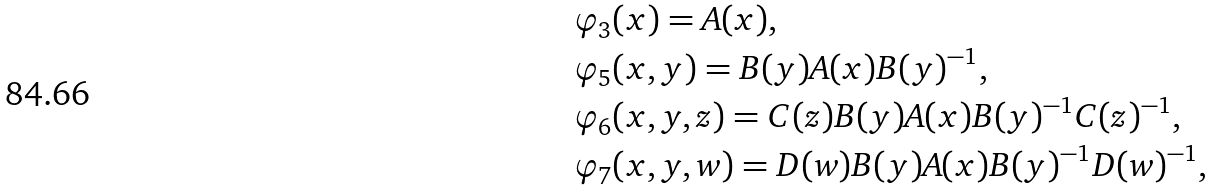<formula> <loc_0><loc_0><loc_500><loc_500>& \varphi _ { 3 } ( { x } ) = A ( { x } ) , \\ & \varphi _ { 5 } ( { x } , { y } ) = B ( { y } ) A ( { x } ) B ( { y } ) ^ { - 1 } , \\ & \varphi _ { 6 } ( { x } , { y } , { z } ) = C ( { z } ) B ( { y } ) A ( { x } ) B ( { y } ) ^ { - 1 } C ( { z } ) ^ { - 1 } , \\ & \varphi _ { 7 } ( { x } , { y } , { w } ) = D ( { w } ) B ( { y } ) A ( { x } ) B ( { y } ) ^ { - 1 } D ( { w } ) ^ { - 1 } ,</formula> 